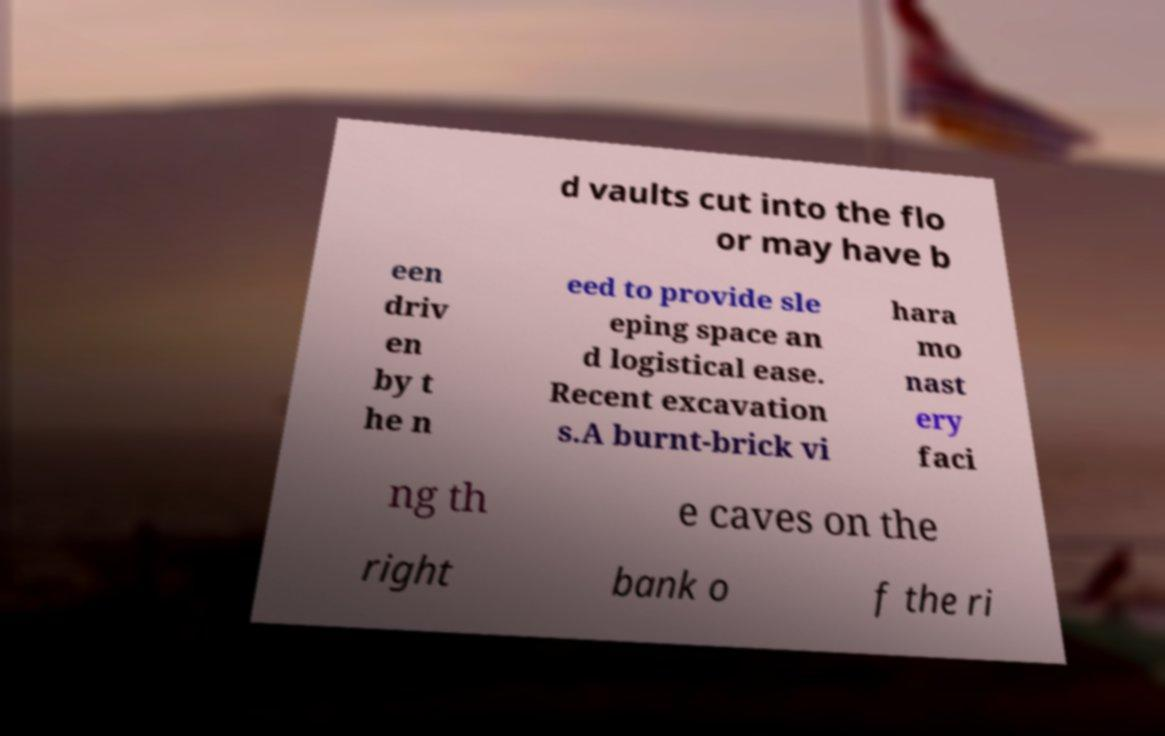Can you read and provide the text displayed in the image?This photo seems to have some interesting text. Can you extract and type it out for me? d vaults cut into the flo or may have b een driv en by t he n eed to provide sle eping space an d logistical ease. Recent excavation s.A burnt-brick vi hara mo nast ery faci ng th e caves on the right bank o f the ri 